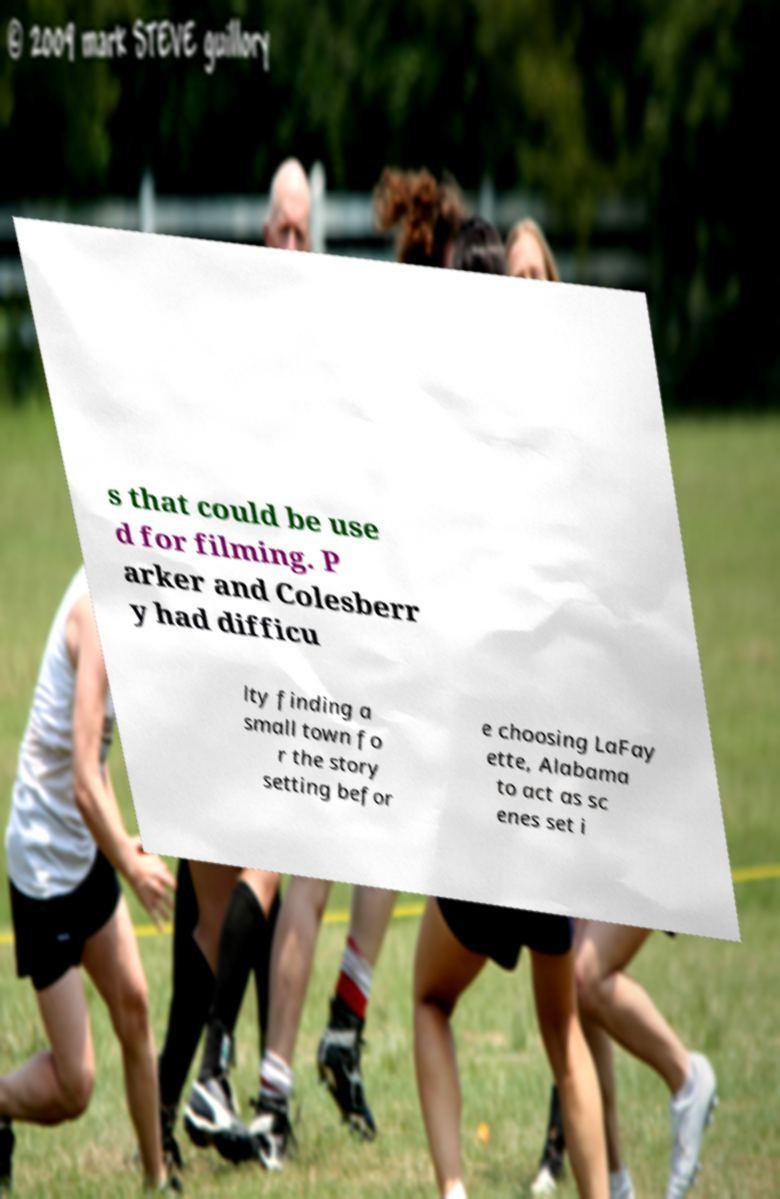There's text embedded in this image that I need extracted. Can you transcribe it verbatim? s that could be use d for filming. P arker and Colesberr y had difficu lty finding a small town fo r the story setting befor e choosing LaFay ette, Alabama to act as sc enes set i 